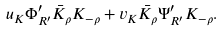<formula> <loc_0><loc_0><loc_500><loc_500>u _ { K } \Phi ^ { \prime } _ { R ^ { \prime } } \bar { K } _ { \rho } K _ { - \rho } + v _ { K } \bar { K } _ { \rho } \Psi ^ { \prime } _ { R ^ { \prime } } K _ { - \rho } .</formula> 